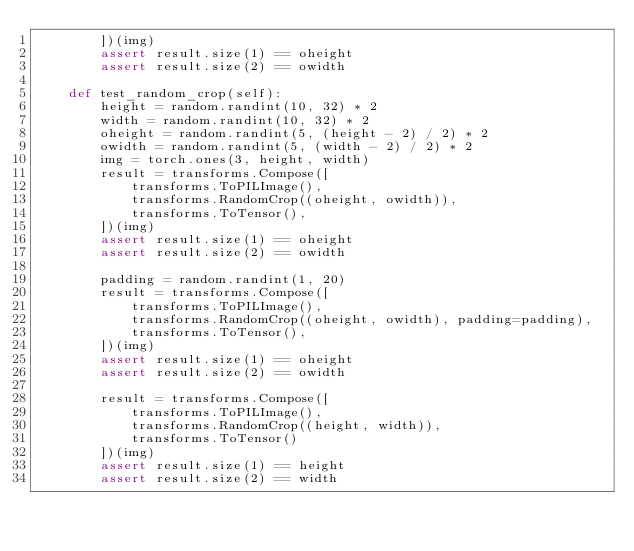<code> <loc_0><loc_0><loc_500><loc_500><_Python_>        ])(img)
        assert result.size(1) == oheight
        assert result.size(2) == owidth

    def test_random_crop(self):
        height = random.randint(10, 32) * 2
        width = random.randint(10, 32) * 2
        oheight = random.randint(5, (height - 2) / 2) * 2
        owidth = random.randint(5, (width - 2) / 2) * 2
        img = torch.ones(3, height, width)
        result = transforms.Compose([
            transforms.ToPILImage(),
            transforms.RandomCrop((oheight, owidth)),
            transforms.ToTensor(),
        ])(img)
        assert result.size(1) == oheight
        assert result.size(2) == owidth

        padding = random.randint(1, 20)
        result = transforms.Compose([
            transforms.ToPILImage(),
            transforms.RandomCrop((oheight, owidth), padding=padding),
            transforms.ToTensor(),
        ])(img)
        assert result.size(1) == oheight
        assert result.size(2) == owidth

        result = transforms.Compose([
            transforms.ToPILImage(),
            transforms.RandomCrop((height, width)),
            transforms.ToTensor()
        ])(img)
        assert result.size(1) == height
        assert result.size(2) == width</code> 